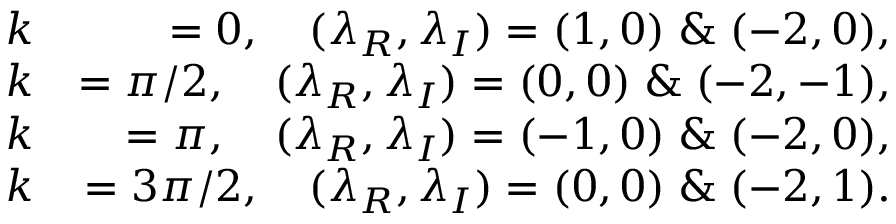<formula> <loc_0><loc_0><loc_500><loc_500>\begin{array} { r l r } & { k } & { = 0 , ( \lambda _ { R } , \lambda _ { I } ) = ( 1 , 0 ) \, \& \, ( - 2 , 0 ) , } \\ & { k } & { = \pi / 2 , ( \lambda _ { R } , \lambda _ { I } ) = ( 0 , 0 ) \, \& \, ( - 2 , - 1 ) , } \\ & { k } & { = \pi , ( \lambda _ { R } , \lambda _ { I } ) = ( - 1 , 0 ) \, \& \, ( - 2 , 0 ) , } \\ & { k } & { = 3 \pi / 2 , ( \lambda _ { R } , \lambda _ { I } ) = ( 0 , 0 ) \, \& \, ( - 2 , 1 ) . } \end{array}</formula> 